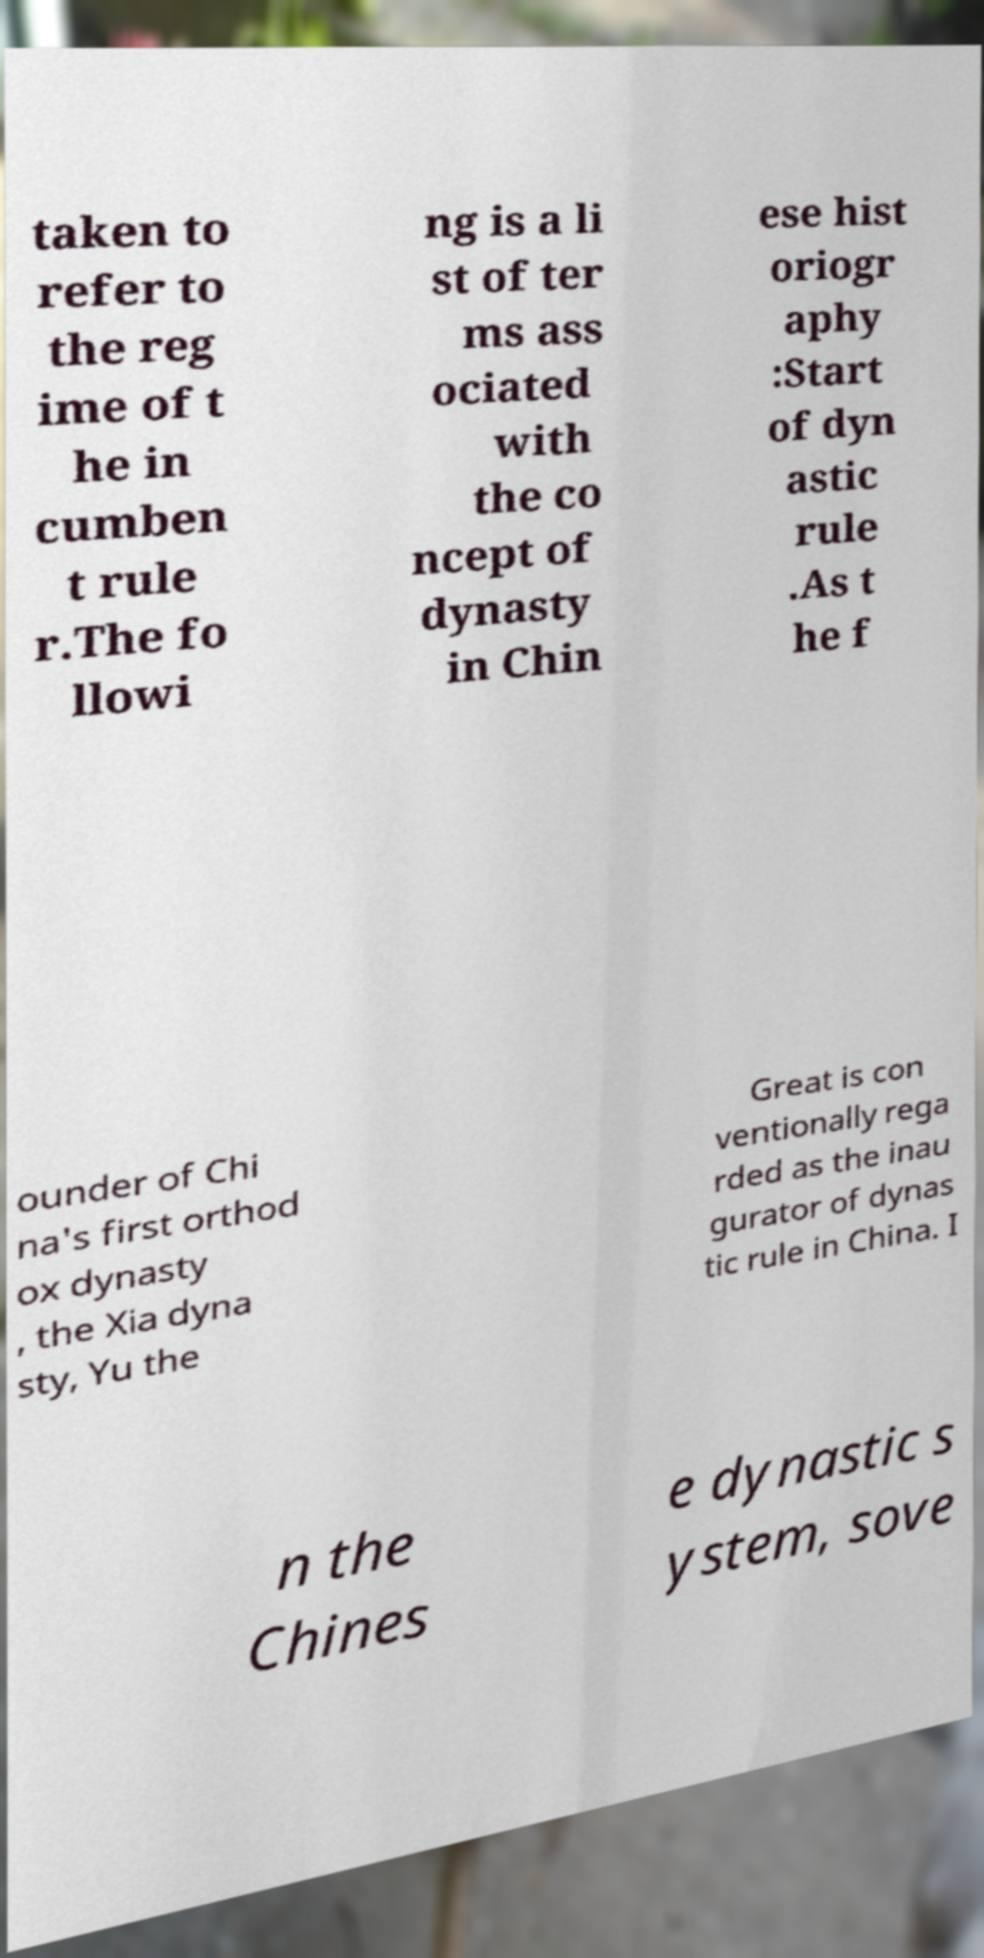Could you assist in decoding the text presented in this image and type it out clearly? taken to refer to the reg ime of t he in cumben t rule r.The fo llowi ng is a li st of ter ms ass ociated with the co ncept of dynasty in Chin ese hist oriogr aphy :Start of dyn astic rule .As t he f ounder of Chi na's first orthod ox dynasty , the Xia dyna sty, Yu the Great is con ventionally rega rded as the inau gurator of dynas tic rule in China. I n the Chines e dynastic s ystem, sove 